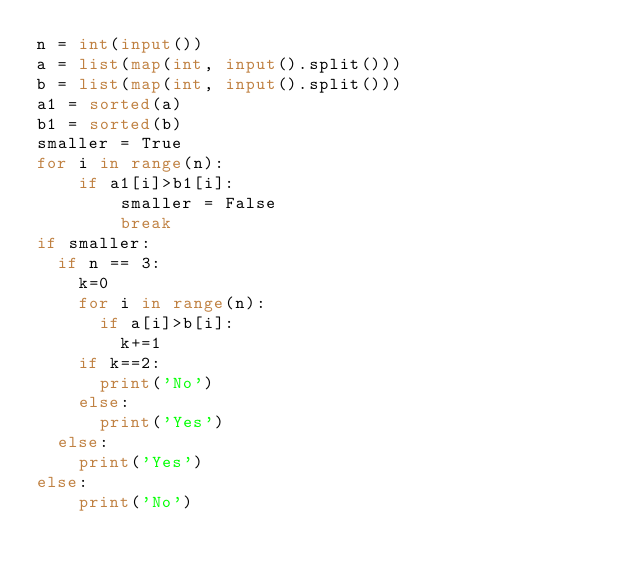<code> <loc_0><loc_0><loc_500><loc_500><_Python_>n = int(input())
a = list(map(int, input().split()))
b = list(map(int, input().split()))
a1 = sorted(a)
b1 = sorted(b)
smaller = True
for i in range(n):
    if a1[i]>b1[i]:
        smaller = False
        break
if smaller:
  if n == 3:
    k=0
    for i in range(n):
      if a[i]>b[i]:
        k+=1
    if k==2:
      print('No')
    else:
      print('Yes')
  else:
    print('Yes')
else:
    print('No')</code> 